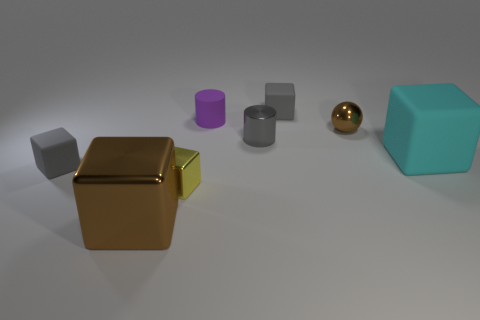Are there more tiny shiny spheres to the left of the tiny shiny cube than tiny gray cubes that are in front of the purple rubber cylinder?
Provide a succinct answer. No. There is a brown thing that is the same size as the purple object; what is it made of?
Give a very brief answer. Metal. How many other objects are the same material as the tiny gray cylinder?
Make the answer very short. 3. Do the tiny gray rubber thing that is right of the small yellow object and the big thing in front of the tiny yellow metal object have the same shape?
Make the answer very short. Yes. What number of other objects are there of the same color as the tiny rubber cylinder?
Your answer should be compact. 0. Are the large cube left of the purple rubber cylinder and the large thing that is to the right of the tiny yellow metallic thing made of the same material?
Provide a succinct answer. No. Is the number of tiny metal objects that are behind the cyan rubber cube the same as the number of objects that are behind the brown metallic sphere?
Keep it short and to the point. Yes. There is a large object that is on the right side of the tiny purple matte cylinder; what is it made of?
Make the answer very short. Rubber. Are there fewer purple cylinders than things?
Give a very brief answer. Yes. There is a small matte object that is both left of the small metallic cylinder and on the right side of the large brown thing; what is its shape?
Offer a terse response. Cylinder. 